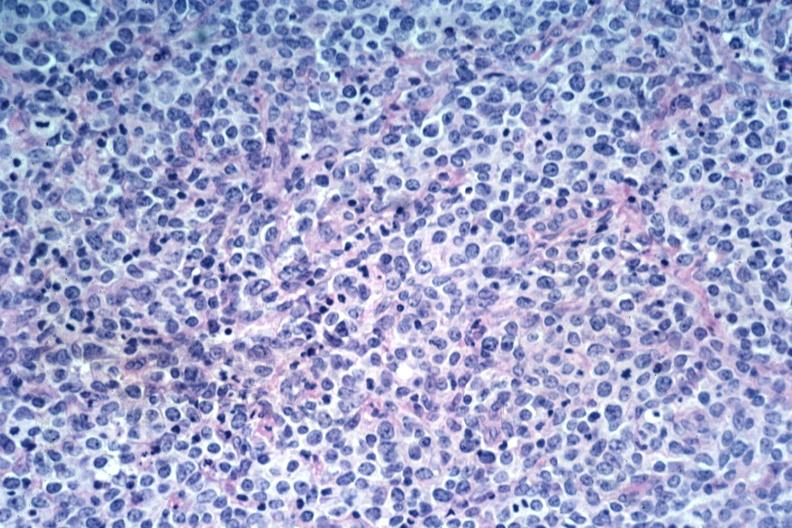s lymph node present?
Answer the question using a single word or phrase. Yes 